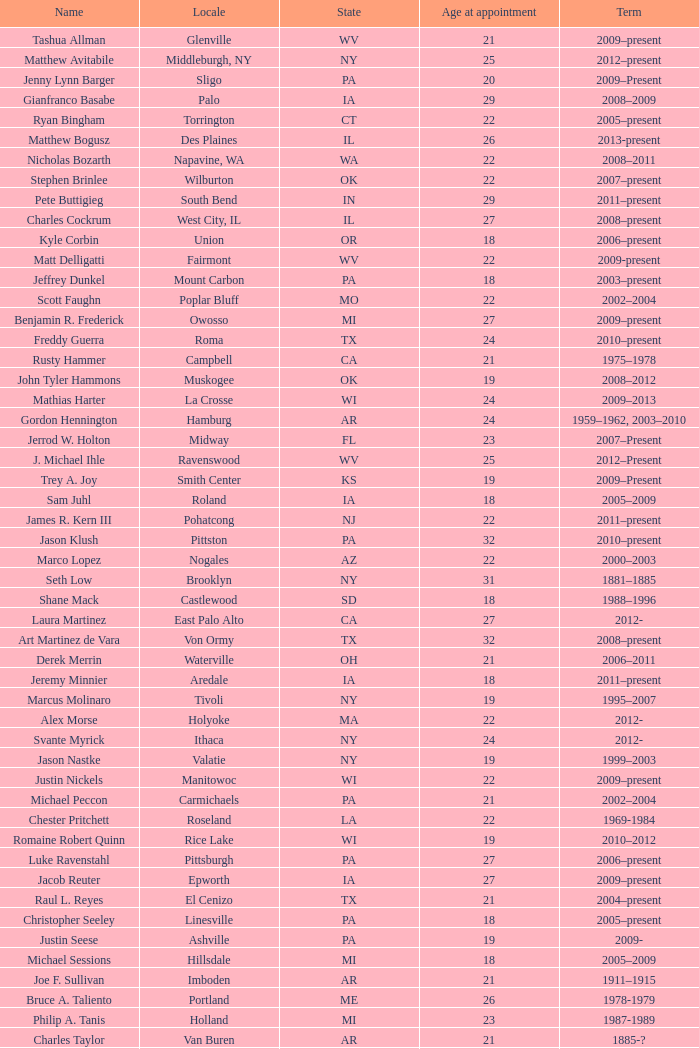What is the name of the holland locale Philip A. Tanis. Would you be able to parse every entry in this table? {'header': ['Name', 'Locale', 'State', 'Age at appointment', 'Term'], 'rows': [['Tashua Allman', 'Glenville', 'WV', '21', '2009–present'], ['Matthew Avitabile', 'Middleburgh, NY', 'NY', '25', '2012–present'], ['Jenny Lynn Barger', 'Sligo', 'PA', '20', '2009–Present'], ['Gianfranco Basabe', 'Palo', 'IA', '29', '2008–2009'], ['Ryan Bingham', 'Torrington', 'CT', '22', '2005–present'], ['Matthew Bogusz', 'Des Plaines', 'IL', '26', '2013-present'], ['Nicholas Bozarth', 'Napavine, WA', 'WA', '22', '2008–2011'], ['Stephen Brinlee', 'Wilburton', 'OK', '22', '2007–present'], ['Pete Buttigieg', 'South Bend', 'IN', '29', '2011–present'], ['Charles Cockrum', 'West City, IL', 'IL', '27', '2008–present'], ['Kyle Corbin', 'Union', 'OR', '18', '2006–present'], ['Matt Delligatti', 'Fairmont', 'WV', '22', '2009-present'], ['Jeffrey Dunkel', 'Mount Carbon', 'PA', '18', '2003–present'], ['Scott Faughn', 'Poplar Bluff', 'MO', '22', '2002–2004'], ['Benjamin R. Frederick', 'Owosso', 'MI', '27', '2009–present'], ['Freddy Guerra', 'Roma', 'TX', '24', '2010–present'], ['Rusty Hammer', 'Campbell', 'CA', '21', '1975–1978'], ['John Tyler Hammons', 'Muskogee', 'OK', '19', '2008–2012'], ['Mathias Harter', 'La Crosse', 'WI', '24', '2009–2013'], ['Gordon Hennington', 'Hamburg', 'AR', '24', '1959–1962, 2003–2010'], ['Jerrod W. Holton', 'Midway', 'FL', '23', '2007–Present'], ['J. Michael Ihle', 'Ravenswood', 'WV', '25', '2012–Present'], ['Trey A. Joy', 'Smith Center', 'KS', '19', '2009–Present'], ['Sam Juhl', 'Roland', 'IA', '18', '2005–2009'], ['James R. Kern III', 'Pohatcong', 'NJ', '22', '2011–present'], ['Jason Klush', 'Pittston', 'PA', '32', '2010–present'], ['Marco Lopez', 'Nogales', 'AZ', '22', '2000–2003'], ['Seth Low', 'Brooklyn', 'NY', '31', '1881–1885'], ['Shane Mack', 'Castlewood', 'SD', '18', '1988–1996'], ['Laura Martinez', 'East Palo Alto', 'CA', '27', '2012-'], ['Art Martinez de Vara', 'Von Ormy', 'TX', '32', '2008–present'], ['Derek Merrin', 'Waterville', 'OH', '21', '2006–2011'], ['Jeremy Minnier', 'Aredale', 'IA', '18', '2011–present'], ['Marcus Molinaro', 'Tivoli', 'NY', '19', '1995–2007'], ['Alex Morse', 'Holyoke', 'MA', '22', '2012-'], ['Svante Myrick', 'Ithaca', 'NY', '24', '2012-'], ['Jason Nastke', 'Valatie', 'NY', '19', '1999–2003'], ['Justin Nickels', 'Manitowoc', 'WI', '22', '2009–present'], ['Michael Peccon', 'Carmichaels', 'PA', '21', '2002–2004'], ['Chester Pritchett', 'Roseland', 'LA', '22', '1969-1984'], ['Romaine Robert Quinn', 'Rice Lake', 'WI', '19', '2010–2012'], ['Luke Ravenstahl', 'Pittsburgh', 'PA', '27', '2006–present'], ['Jacob Reuter', 'Epworth', 'IA', '27', '2009–present'], ['Raul L. Reyes', 'El Cenizo', 'TX', '21', '2004–present'], ['Christopher Seeley', 'Linesville', 'PA', '18', '2005–present'], ['Justin Seese', 'Ashville', 'PA', '19', '2009-'], ['Michael Sessions', 'Hillsdale', 'MI', '18', '2005–2009'], ['Joe F. Sullivan', 'Imboden', 'AR', '21', '1911–1915'], ['Bruce A. Taliento', 'Portland', 'ME', '26', '1978-1979'], ['Philip A. Tanis', 'Holland', 'MI', '23', '1987-1989'], ['Charles Taylor', 'Van Buren', 'AR', '21', '1885-?'], ['Willie Morgan Todd', 'Mount Juliet', 'TN', '21', '2012–present'], ['Tye Thomas', 'Gun Barrel City, Texas', 'TX', '21', '2000-2001'], ['Robert Tufts', 'Dorset', 'MN', '4', '2013'], ['Zachary J. Vruwink', 'Wisconsin Rapids, WI', 'WI', '24', '2012–present'], ['Jason West', 'New Paltz', 'NY', '26', '2003–2007'], ['Olivia Webb', 'Ellerbe, NC', 'NC', '25', '2009–present'], ['Jeremy Wilson', 'Blossom, Texas', 'TX', '24', '2010–present'], ['Jeremy Yamaguchi', 'Placentia', 'CA', '22', '2012–'], ['Harry Zikas, Jr.', 'Alpha', 'NJ', '21', '2000–2007'], ['Brian Zimmerman', 'Crabb', 'TX', '11', '1983 - ?']]} 